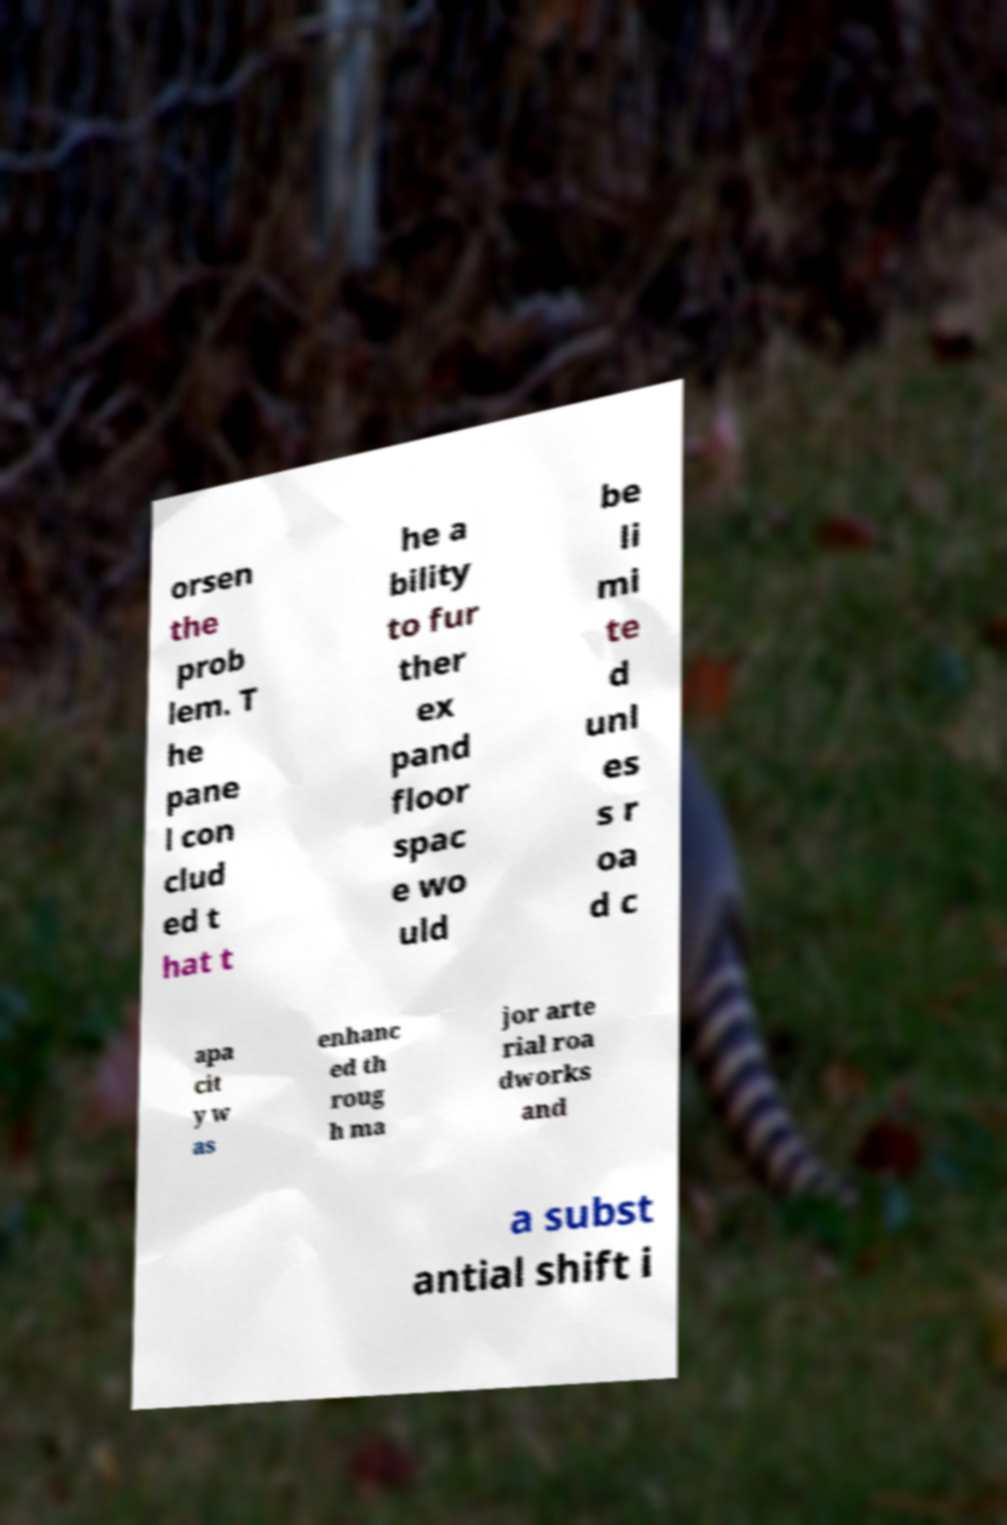For documentation purposes, I need the text within this image transcribed. Could you provide that? orsen the prob lem. T he pane l con clud ed t hat t he a bility to fur ther ex pand floor spac e wo uld be li mi te d unl es s r oa d c apa cit y w as enhanc ed th roug h ma jor arte rial roa dworks and a subst antial shift i 